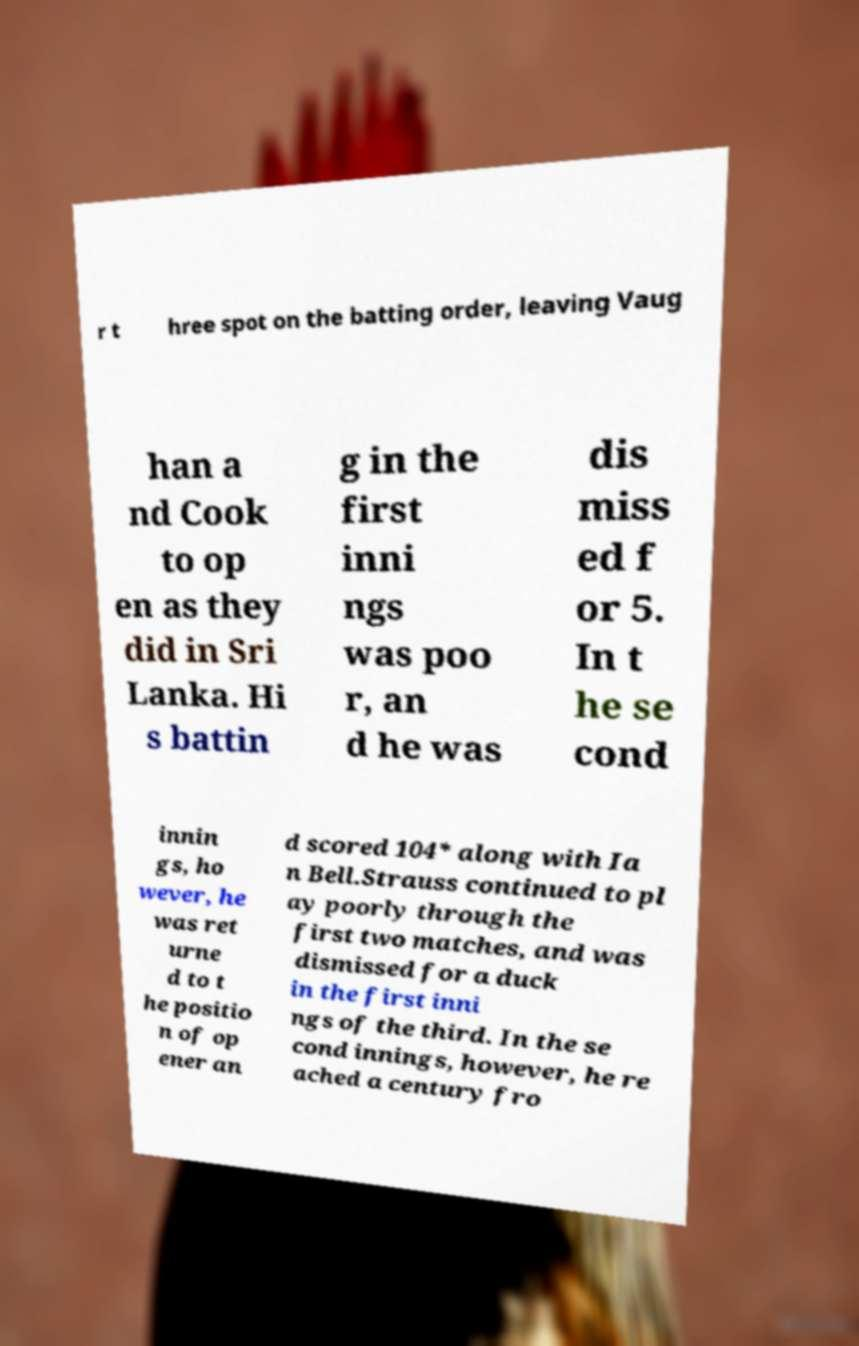Could you assist in decoding the text presented in this image and type it out clearly? r t hree spot on the batting order, leaving Vaug han a nd Cook to op en as they did in Sri Lanka. Hi s battin g in the first inni ngs was poo r, an d he was dis miss ed f or 5. In t he se cond innin gs, ho wever, he was ret urne d to t he positio n of op ener an d scored 104* along with Ia n Bell.Strauss continued to pl ay poorly through the first two matches, and was dismissed for a duck in the first inni ngs of the third. In the se cond innings, however, he re ached a century fro 